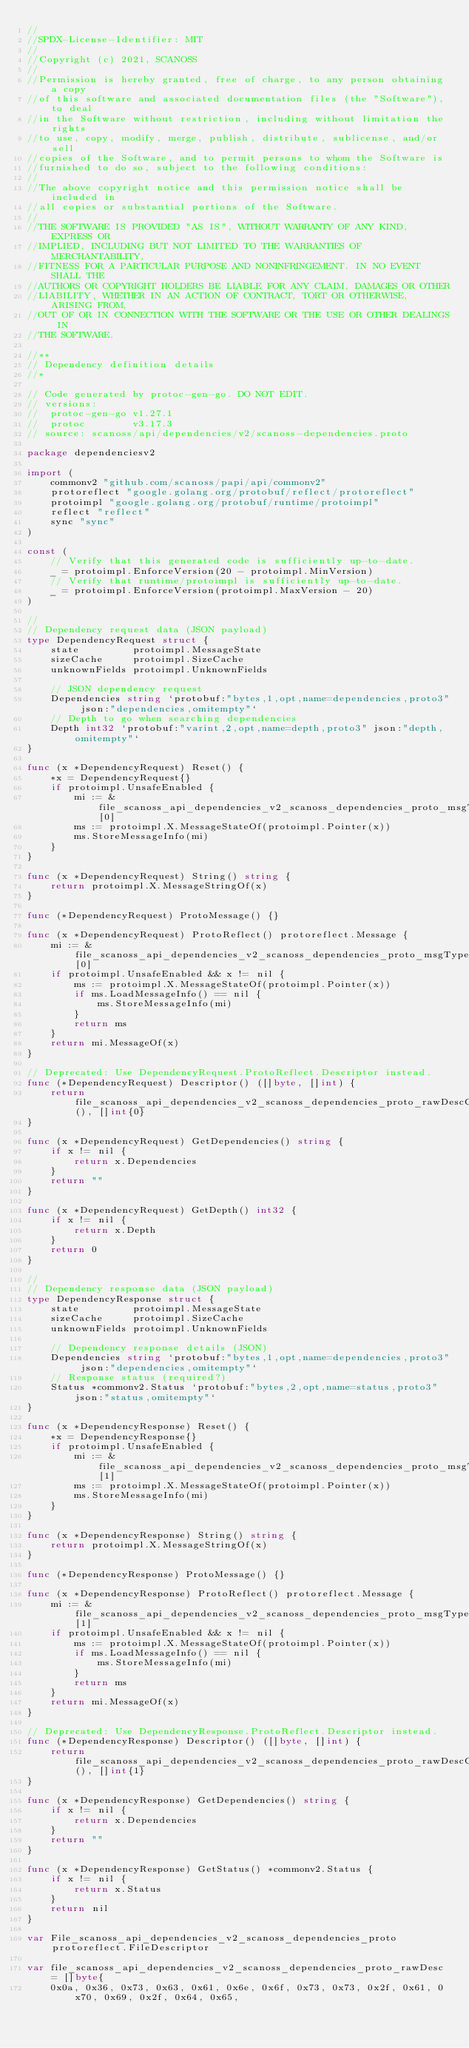<code> <loc_0><loc_0><loc_500><loc_500><_Go_>//
//SPDX-License-Identifier: MIT
//
//Copyright (c) 2021, SCANOSS
//
//Permission is hereby granted, free of charge, to any person obtaining a copy
//of this software and associated documentation files (the "Software"), to deal
//in the Software without restriction, including without limitation the rights
//to use, copy, modify, merge, publish, distribute, sublicense, and/or sell
//copies of the Software, and to permit persons to whom the Software is
//furnished to do so, subject to the following conditions:
//
//The above copyright notice and this permission notice shall be included in
//all copies or substantial portions of the Software.
//
//THE SOFTWARE IS PROVIDED "AS IS", WITHOUT WARRANTY OF ANY KIND, EXPRESS OR
//IMPLIED, INCLUDING BUT NOT LIMITED TO THE WARRANTIES OF MERCHANTABILITY,
//FITNESS FOR A PARTICULAR PURPOSE AND NONINFRINGEMENT. IN NO EVENT SHALL THE
//AUTHORS OR COPYRIGHT HOLDERS BE LIABLE FOR ANY CLAIM, DAMAGES OR OTHER
//LIABILITY, WHETHER IN AN ACTION OF CONTRACT, TORT OR OTHERWISE, ARISING FROM,
//OUT OF OR IN CONNECTION WITH THE SOFTWARE OR THE USE OR OTHER DEALINGS IN
//THE SOFTWARE.

//**
// Dependency definition details
//*

// Code generated by protoc-gen-go. DO NOT EDIT.
// versions:
// 	protoc-gen-go v1.27.1
// 	protoc        v3.17.3
// source: scanoss/api/dependencies/v2/scanoss-dependencies.proto

package dependenciesv2

import (
	commonv2 "github.com/scanoss/papi/api/commonv2"
	protoreflect "google.golang.org/protobuf/reflect/protoreflect"
	protoimpl "google.golang.org/protobuf/runtime/protoimpl"
	reflect "reflect"
	sync "sync"
)

const (
	// Verify that this generated code is sufficiently up-to-date.
	_ = protoimpl.EnforceVersion(20 - protoimpl.MinVersion)
	// Verify that runtime/protoimpl is sufficiently up-to-date.
	_ = protoimpl.EnforceVersion(protoimpl.MaxVersion - 20)
)

//
// Dependency request data (JSON payload)
type DependencyRequest struct {
	state         protoimpl.MessageState
	sizeCache     protoimpl.SizeCache
	unknownFields protoimpl.UnknownFields

	// JSON dependency request
	Dependencies string `protobuf:"bytes,1,opt,name=dependencies,proto3" json:"dependencies,omitempty"`
	// Depth to go when searching dependencies
	Depth int32 `protobuf:"varint,2,opt,name=depth,proto3" json:"depth,omitempty"`
}

func (x *DependencyRequest) Reset() {
	*x = DependencyRequest{}
	if protoimpl.UnsafeEnabled {
		mi := &file_scanoss_api_dependencies_v2_scanoss_dependencies_proto_msgTypes[0]
		ms := protoimpl.X.MessageStateOf(protoimpl.Pointer(x))
		ms.StoreMessageInfo(mi)
	}
}

func (x *DependencyRequest) String() string {
	return protoimpl.X.MessageStringOf(x)
}

func (*DependencyRequest) ProtoMessage() {}

func (x *DependencyRequest) ProtoReflect() protoreflect.Message {
	mi := &file_scanoss_api_dependencies_v2_scanoss_dependencies_proto_msgTypes[0]
	if protoimpl.UnsafeEnabled && x != nil {
		ms := protoimpl.X.MessageStateOf(protoimpl.Pointer(x))
		if ms.LoadMessageInfo() == nil {
			ms.StoreMessageInfo(mi)
		}
		return ms
	}
	return mi.MessageOf(x)
}

// Deprecated: Use DependencyRequest.ProtoReflect.Descriptor instead.
func (*DependencyRequest) Descriptor() ([]byte, []int) {
	return file_scanoss_api_dependencies_v2_scanoss_dependencies_proto_rawDescGZIP(), []int{0}
}

func (x *DependencyRequest) GetDependencies() string {
	if x != nil {
		return x.Dependencies
	}
	return ""
}

func (x *DependencyRequest) GetDepth() int32 {
	if x != nil {
		return x.Depth
	}
	return 0
}

//
// Dependency response data (JSON payload)
type DependencyResponse struct {
	state         protoimpl.MessageState
	sizeCache     protoimpl.SizeCache
	unknownFields protoimpl.UnknownFields

	// Dependency response details (JSON)
	Dependencies string `protobuf:"bytes,1,opt,name=dependencies,proto3" json:"dependencies,omitempty"`
	// Response status (required?)
	Status *commonv2.Status `protobuf:"bytes,2,opt,name=status,proto3" json:"status,omitempty"`
}

func (x *DependencyResponse) Reset() {
	*x = DependencyResponse{}
	if protoimpl.UnsafeEnabled {
		mi := &file_scanoss_api_dependencies_v2_scanoss_dependencies_proto_msgTypes[1]
		ms := protoimpl.X.MessageStateOf(protoimpl.Pointer(x))
		ms.StoreMessageInfo(mi)
	}
}

func (x *DependencyResponse) String() string {
	return protoimpl.X.MessageStringOf(x)
}

func (*DependencyResponse) ProtoMessage() {}

func (x *DependencyResponse) ProtoReflect() protoreflect.Message {
	mi := &file_scanoss_api_dependencies_v2_scanoss_dependencies_proto_msgTypes[1]
	if protoimpl.UnsafeEnabled && x != nil {
		ms := protoimpl.X.MessageStateOf(protoimpl.Pointer(x))
		if ms.LoadMessageInfo() == nil {
			ms.StoreMessageInfo(mi)
		}
		return ms
	}
	return mi.MessageOf(x)
}

// Deprecated: Use DependencyResponse.ProtoReflect.Descriptor instead.
func (*DependencyResponse) Descriptor() ([]byte, []int) {
	return file_scanoss_api_dependencies_v2_scanoss_dependencies_proto_rawDescGZIP(), []int{1}
}

func (x *DependencyResponse) GetDependencies() string {
	if x != nil {
		return x.Dependencies
	}
	return ""
}

func (x *DependencyResponse) GetStatus() *commonv2.Status {
	if x != nil {
		return x.Status
	}
	return nil
}

var File_scanoss_api_dependencies_v2_scanoss_dependencies_proto protoreflect.FileDescriptor

var file_scanoss_api_dependencies_v2_scanoss_dependencies_proto_rawDesc = []byte{
	0x0a, 0x36, 0x73, 0x63, 0x61, 0x6e, 0x6f, 0x73, 0x73, 0x2f, 0x61, 0x70, 0x69, 0x2f, 0x64, 0x65,</code> 